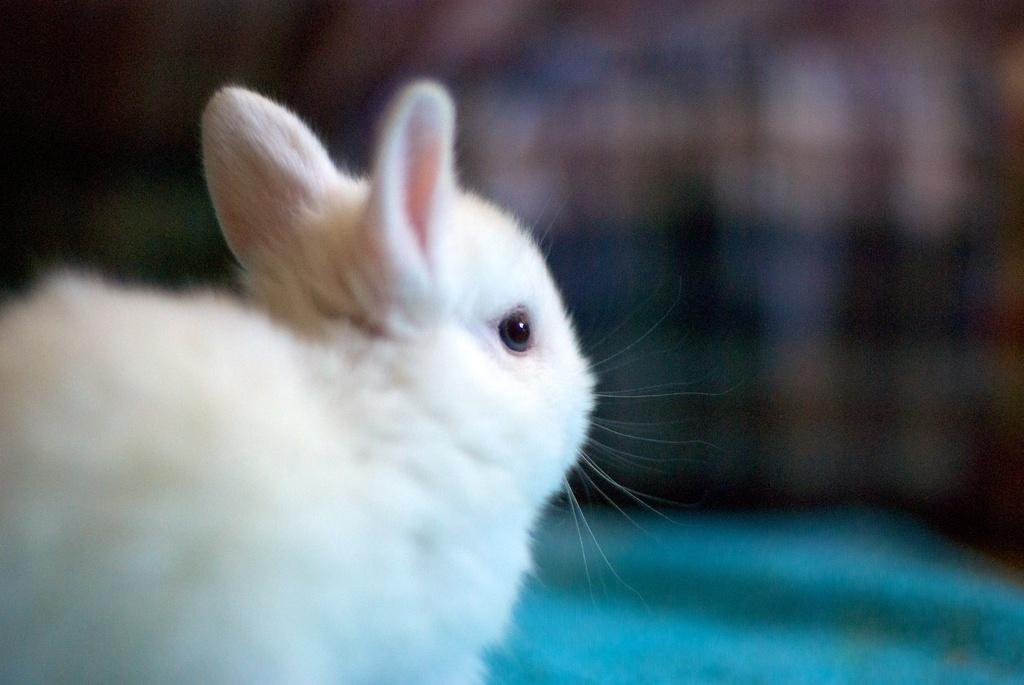What animal is present in the image? There is a rabbit in the image. What is the color of the rabbit? The rabbit is white in color. Can you describe the background of the image? The background of the image is blurred. What type of popcorn is being served at the rabbit's birthday party in the image? There is no popcorn or birthday party present in the image; it features a white rabbit with a blurred background. 